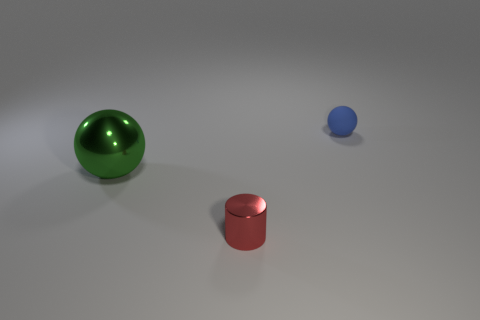What materials do the objects in the image look like they're made of? The objects in the image appear to have a reflective surface, suggesting they could be made of materials like polished metal or smooth plastic. 